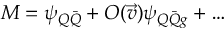Convert formula to latex. <formula><loc_0><loc_0><loc_500><loc_500>M = \psi _ { Q \bar { Q } } + O ( \vec { v } ) \psi _ { Q \bar { Q } g } + \dots</formula> 